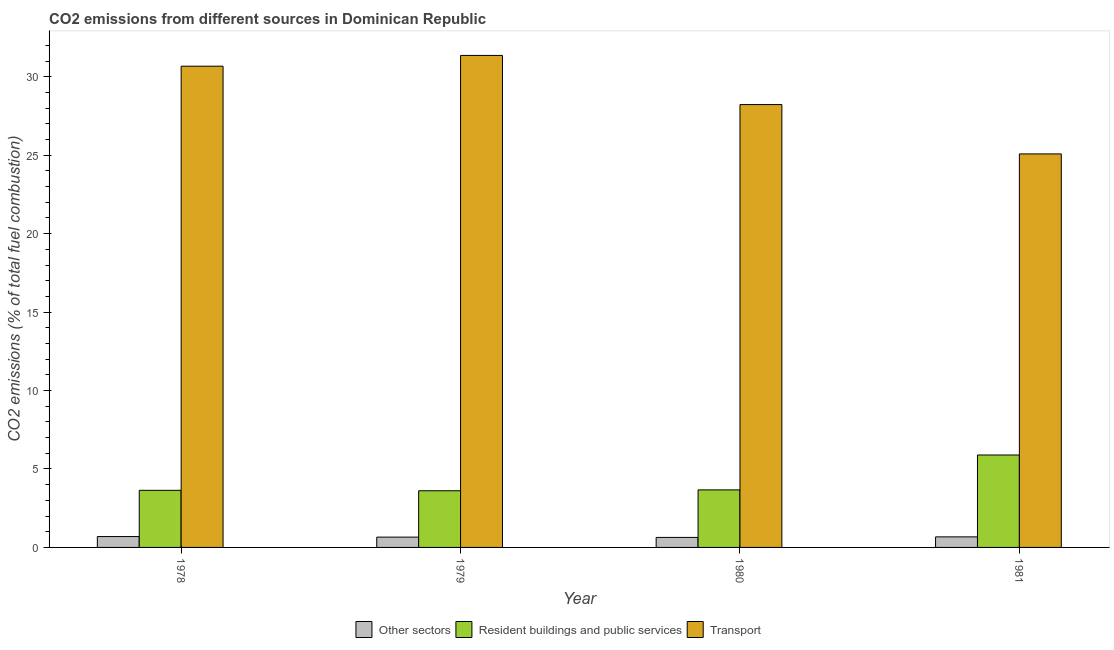How many bars are there on the 3rd tick from the left?
Provide a succinct answer. 3. How many bars are there on the 3rd tick from the right?
Provide a succinct answer. 3. What is the label of the 1st group of bars from the left?
Ensure brevity in your answer.  1978. In how many cases, is the number of bars for a given year not equal to the number of legend labels?
Offer a very short reply. 0. What is the percentage of co2 emissions from other sectors in 1978?
Give a very brief answer. 0.69. Across all years, what is the maximum percentage of co2 emissions from other sectors?
Ensure brevity in your answer.  0.69. Across all years, what is the minimum percentage of co2 emissions from transport?
Offer a terse response. 25.08. In which year was the percentage of co2 emissions from resident buildings and public services minimum?
Offer a terse response. 1979. What is the total percentage of co2 emissions from other sectors in the graph?
Provide a short and direct response. 2.66. What is the difference between the percentage of co2 emissions from resident buildings and public services in 1978 and that in 1979?
Offer a terse response. 0.03. What is the difference between the percentage of co2 emissions from transport in 1978 and the percentage of co2 emissions from other sectors in 1979?
Keep it short and to the point. -0.69. What is the average percentage of co2 emissions from other sectors per year?
Your response must be concise. 0.67. What is the ratio of the percentage of co2 emissions from resident buildings and public services in 1979 to that in 1980?
Keep it short and to the point. 0.98. Is the percentage of co2 emissions from transport in 1979 less than that in 1980?
Provide a succinct answer. No. What is the difference between the highest and the second highest percentage of co2 emissions from transport?
Provide a short and direct response. 0.69. What is the difference between the highest and the lowest percentage of co2 emissions from transport?
Offer a terse response. 6.28. In how many years, is the percentage of co2 emissions from other sectors greater than the average percentage of co2 emissions from other sectors taken over all years?
Provide a short and direct response. 2. Is the sum of the percentage of co2 emissions from transport in 1979 and 1980 greater than the maximum percentage of co2 emissions from resident buildings and public services across all years?
Keep it short and to the point. Yes. What does the 2nd bar from the left in 1980 represents?
Ensure brevity in your answer.  Resident buildings and public services. What does the 3rd bar from the right in 1979 represents?
Keep it short and to the point. Other sectors. What is the title of the graph?
Ensure brevity in your answer.  CO2 emissions from different sources in Dominican Republic. Does "Renewable sources" appear as one of the legend labels in the graph?
Provide a short and direct response. No. What is the label or title of the Y-axis?
Make the answer very short. CO2 emissions (% of total fuel combustion). What is the CO2 emissions (% of total fuel combustion) of Other sectors in 1978?
Your response must be concise. 0.69. What is the CO2 emissions (% of total fuel combustion) of Resident buildings and public services in 1978?
Provide a succinct answer. 3.64. What is the CO2 emissions (% of total fuel combustion) of Transport in 1978?
Make the answer very short. 30.68. What is the CO2 emissions (% of total fuel combustion) in Other sectors in 1979?
Make the answer very short. 0.66. What is the CO2 emissions (% of total fuel combustion) of Resident buildings and public services in 1979?
Provide a short and direct response. 3.61. What is the CO2 emissions (% of total fuel combustion) of Transport in 1979?
Provide a short and direct response. 31.36. What is the CO2 emissions (% of total fuel combustion) of Other sectors in 1980?
Make the answer very short. 0.64. What is the CO2 emissions (% of total fuel combustion) of Resident buildings and public services in 1980?
Your answer should be very brief. 3.67. What is the CO2 emissions (% of total fuel combustion) of Transport in 1980?
Provide a succinct answer. 28.23. What is the CO2 emissions (% of total fuel combustion) in Other sectors in 1981?
Give a very brief answer. 0.67. What is the CO2 emissions (% of total fuel combustion) of Resident buildings and public services in 1981?
Make the answer very short. 5.89. What is the CO2 emissions (% of total fuel combustion) of Transport in 1981?
Keep it short and to the point. 25.08. Across all years, what is the maximum CO2 emissions (% of total fuel combustion) in Other sectors?
Your answer should be compact. 0.69. Across all years, what is the maximum CO2 emissions (% of total fuel combustion) in Resident buildings and public services?
Provide a short and direct response. 5.89. Across all years, what is the maximum CO2 emissions (% of total fuel combustion) in Transport?
Give a very brief answer. 31.36. Across all years, what is the minimum CO2 emissions (% of total fuel combustion) of Other sectors?
Your answer should be compact. 0.64. Across all years, what is the minimum CO2 emissions (% of total fuel combustion) in Resident buildings and public services?
Provide a succinct answer. 3.61. Across all years, what is the minimum CO2 emissions (% of total fuel combustion) in Transport?
Your answer should be compact. 25.08. What is the total CO2 emissions (% of total fuel combustion) in Other sectors in the graph?
Give a very brief answer. 2.66. What is the total CO2 emissions (% of total fuel combustion) in Resident buildings and public services in the graph?
Offer a terse response. 16.81. What is the total CO2 emissions (% of total fuel combustion) of Transport in the graph?
Offer a terse response. 115.35. What is the difference between the CO2 emissions (% of total fuel combustion) in Other sectors in 1978 and that in 1979?
Your answer should be very brief. 0.04. What is the difference between the CO2 emissions (% of total fuel combustion) in Resident buildings and public services in 1978 and that in 1979?
Provide a succinct answer. 0.03. What is the difference between the CO2 emissions (% of total fuel combustion) in Transport in 1978 and that in 1979?
Make the answer very short. -0.69. What is the difference between the CO2 emissions (% of total fuel combustion) of Other sectors in 1978 and that in 1980?
Offer a terse response. 0.06. What is the difference between the CO2 emissions (% of total fuel combustion) of Resident buildings and public services in 1978 and that in 1980?
Provide a succinct answer. -0.03. What is the difference between the CO2 emissions (% of total fuel combustion) of Transport in 1978 and that in 1980?
Make the answer very short. 2.45. What is the difference between the CO2 emissions (% of total fuel combustion) of Other sectors in 1978 and that in 1981?
Offer a very short reply. 0.02. What is the difference between the CO2 emissions (% of total fuel combustion) in Resident buildings and public services in 1978 and that in 1981?
Provide a short and direct response. -2.25. What is the difference between the CO2 emissions (% of total fuel combustion) of Transport in 1978 and that in 1981?
Keep it short and to the point. 5.59. What is the difference between the CO2 emissions (% of total fuel combustion) of Other sectors in 1979 and that in 1980?
Offer a very short reply. 0.02. What is the difference between the CO2 emissions (% of total fuel combustion) in Resident buildings and public services in 1979 and that in 1980?
Offer a terse response. -0.06. What is the difference between the CO2 emissions (% of total fuel combustion) of Transport in 1979 and that in 1980?
Ensure brevity in your answer.  3.13. What is the difference between the CO2 emissions (% of total fuel combustion) in Other sectors in 1979 and that in 1981?
Offer a terse response. -0.02. What is the difference between the CO2 emissions (% of total fuel combustion) in Resident buildings and public services in 1979 and that in 1981?
Offer a very short reply. -2.28. What is the difference between the CO2 emissions (% of total fuel combustion) in Transport in 1979 and that in 1981?
Ensure brevity in your answer.  6.28. What is the difference between the CO2 emissions (% of total fuel combustion) in Other sectors in 1980 and that in 1981?
Your response must be concise. -0.04. What is the difference between the CO2 emissions (% of total fuel combustion) in Resident buildings and public services in 1980 and that in 1981?
Your answer should be compact. -2.22. What is the difference between the CO2 emissions (% of total fuel combustion) in Transport in 1980 and that in 1981?
Offer a terse response. 3.15. What is the difference between the CO2 emissions (% of total fuel combustion) in Other sectors in 1978 and the CO2 emissions (% of total fuel combustion) in Resident buildings and public services in 1979?
Your answer should be very brief. -2.92. What is the difference between the CO2 emissions (% of total fuel combustion) in Other sectors in 1978 and the CO2 emissions (% of total fuel combustion) in Transport in 1979?
Your answer should be very brief. -30.67. What is the difference between the CO2 emissions (% of total fuel combustion) of Resident buildings and public services in 1978 and the CO2 emissions (% of total fuel combustion) of Transport in 1979?
Make the answer very short. -27.72. What is the difference between the CO2 emissions (% of total fuel combustion) in Other sectors in 1978 and the CO2 emissions (% of total fuel combustion) in Resident buildings and public services in 1980?
Your response must be concise. -2.98. What is the difference between the CO2 emissions (% of total fuel combustion) in Other sectors in 1978 and the CO2 emissions (% of total fuel combustion) in Transport in 1980?
Your response must be concise. -27.54. What is the difference between the CO2 emissions (% of total fuel combustion) of Resident buildings and public services in 1978 and the CO2 emissions (% of total fuel combustion) of Transport in 1980?
Provide a succinct answer. -24.59. What is the difference between the CO2 emissions (% of total fuel combustion) in Other sectors in 1978 and the CO2 emissions (% of total fuel combustion) in Resident buildings and public services in 1981?
Ensure brevity in your answer.  -5.2. What is the difference between the CO2 emissions (% of total fuel combustion) of Other sectors in 1978 and the CO2 emissions (% of total fuel combustion) of Transport in 1981?
Your response must be concise. -24.39. What is the difference between the CO2 emissions (% of total fuel combustion) of Resident buildings and public services in 1978 and the CO2 emissions (% of total fuel combustion) of Transport in 1981?
Make the answer very short. -21.44. What is the difference between the CO2 emissions (% of total fuel combustion) in Other sectors in 1979 and the CO2 emissions (% of total fuel combustion) in Resident buildings and public services in 1980?
Provide a short and direct response. -3.01. What is the difference between the CO2 emissions (% of total fuel combustion) of Other sectors in 1979 and the CO2 emissions (% of total fuel combustion) of Transport in 1980?
Your answer should be very brief. -27.57. What is the difference between the CO2 emissions (% of total fuel combustion) of Resident buildings and public services in 1979 and the CO2 emissions (% of total fuel combustion) of Transport in 1980?
Your answer should be compact. -24.62. What is the difference between the CO2 emissions (% of total fuel combustion) in Other sectors in 1979 and the CO2 emissions (% of total fuel combustion) in Resident buildings and public services in 1981?
Offer a very short reply. -5.24. What is the difference between the CO2 emissions (% of total fuel combustion) in Other sectors in 1979 and the CO2 emissions (% of total fuel combustion) in Transport in 1981?
Offer a very short reply. -24.43. What is the difference between the CO2 emissions (% of total fuel combustion) in Resident buildings and public services in 1979 and the CO2 emissions (% of total fuel combustion) in Transport in 1981?
Your response must be concise. -21.47. What is the difference between the CO2 emissions (% of total fuel combustion) in Other sectors in 1980 and the CO2 emissions (% of total fuel combustion) in Resident buildings and public services in 1981?
Give a very brief answer. -5.25. What is the difference between the CO2 emissions (% of total fuel combustion) in Other sectors in 1980 and the CO2 emissions (% of total fuel combustion) in Transport in 1981?
Your answer should be very brief. -24.45. What is the difference between the CO2 emissions (% of total fuel combustion) of Resident buildings and public services in 1980 and the CO2 emissions (% of total fuel combustion) of Transport in 1981?
Give a very brief answer. -21.42. What is the average CO2 emissions (% of total fuel combustion) in Other sectors per year?
Your answer should be compact. 0.67. What is the average CO2 emissions (% of total fuel combustion) of Resident buildings and public services per year?
Offer a terse response. 4.2. What is the average CO2 emissions (% of total fuel combustion) of Transport per year?
Your answer should be compact. 28.84. In the year 1978, what is the difference between the CO2 emissions (% of total fuel combustion) of Other sectors and CO2 emissions (% of total fuel combustion) of Resident buildings and public services?
Ensure brevity in your answer.  -2.95. In the year 1978, what is the difference between the CO2 emissions (% of total fuel combustion) in Other sectors and CO2 emissions (% of total fuel combustion) in Transport?
Keep it short and to the point. -29.98. In the year 1978, what is the difference between the CO2 emissions (% of total fuel combustion) of Resident buildings and public services and CO2 emissions (% of total fuel combustion) of Transport?
Ensure brevity in your answer.  -27.04. In the year 1979, what is the difference between the CO2 emissions (% of total fuel combustion) in Other sectors and CO2 emissions (% of total fuel combustion) in Resident buildings and public services?
Give a very brief answer. -2.96. In the year 1979, what is the difference between the CO2 emissions (% of total fuel combustion) in Other sectors and CO2 emissions (% of total fuel combustion) in Transport?
Give a very brief answer. -30.71. In the year 1979, what is the difference between the CO2 emissions (% of total fuel combustion) of Resident buildings and public services and CO2 emissions (% of total fuel combustion) of Transport?
Provide a succinct answer. -27.75. In the year 1980, what is the difference between the CO2 emissions (% of total fuel combustion) of Other sectors and CO2 emissions (% of total fuel combustion) of Resident buildings and public services?
Provide a short and direct response. -3.03. In the year 1980, what is the difference between the CO2 emissions (% of total fuel combustion) of Other sectors and CO2 emissions (% of total fuel combustion) of Transport?
Ensure brevity in your answer.  -27.59. In the year 1980, what is the difference between the CO2 emissions (% of total fuel combustion) of Resident buildings and public services and CO2 emissions (% of total fuel combustion) of Transport?
Your answer should be compact. -24.56. In the year 1981, what is the difference between the CO2 emissions (% of total fuel combustion) of Other sectors and CO2 emissions (% of total fuel combustion) of Resident buildings and public services?
Ensure brevity in your answer.  -5.22. In the year 1981, what is the difference between the CO2 emissions (% of total fuel combustion) of Other sectors and CO2 emissions (% of total fuel combustion) of Transport?
Offer a very short reply. -24.41. In the year 1981, what is the difference between the CO2 emissions (% of total fuel combustion) in Resident buildings and public services and CO2 emissions (% of total fuel combustion) in Transport?
Give a very brief answer. -19.19. What is the ratio of the CO2 emissions (% of total fuel combustion) in Other sectors in 1978 to that in 1979?
Make the answer very short. 1.06. What is the ratio of the CO2 emissions (% of total fuel combustion) of Resident buildings and public services in 1978 to that in 1979?
Your answer should be compact. 1.01. What is the ratio of the CO2 emissions (% of total fuel combustion) in Transport in 1978 to that in 1979?
Make the answer very short. 0.98. What is the ratio of the CO2 emissions (% of total fuel combustion) in Other sectors in 1978 to that in 1980?
Offer a very short reply. 1.09. What is the ratio of the CO2 emissions (% of total fuel combustion) in Resident buildings and public services in 1978 to that in 1980?
Your response must be concise. 0.99. What is the ratio of the CO2 emissions (% of total fuel combustion) of Transport in 1978 to that in 1980?
Offer a terse response. 1.09. What is the ratio of the CO2 emissions (% of total fuel combustion) of Other sectors in 1978 to that in 1981?
Make the answer very short. 1.03. What is the ratio of the CO2 emissions (% of total fuel combustion) in Resident buildings and public services in 1978 to that in 1981?
Offer a terse response. 0.62. What is the ratio of the CO2 emissions (% of total fuel combustion) in Transport in 1978 to that in 1981?
Provide a short and direct response. 1.22. What is the ratio of the CO2 emissions (% of total fuel combustion) in Other sectors in 1979 to that in 1980?
Ensure brevity in your answer.  1.03. What is the ratio of the CO2 emissions (% of total fuel combustion) of Resident buildings and public services in 1979 to that in 1980?
Keep it short and to the point. 0.98. What is the ratio of the CO2 emissions (% of total fuel combustion) in Transport in 1979 to that in 1980?
Your answer should be compact. 1.11. What is the ratio of the CO2 emissions (% of total fuel combustion) in Other sectors in 1979 to that in 1981?
Give a very brief answer. 0.98. What is the ratio of the CO2 emissions (% of total fuel combustion) of Resident buildings and public services in 1979 to that in 1981?
Provide a succinct answer. 0.61. What is the ratio of the CO2 emissions (% of total fuel combustion) of Transport in 1979 to that in 1981?
Provide a succinct answer. 1.25. What is the ratio of the CO2 emissions (% of total fuel combustion) in Other sectors in 1980 to that in 1981?
Your answer should be compact. 0.95. What is the ratio of the CO2 emissions (% of total fuel combustion) in Resident buildings and public services in 1980 to that in 1981?
Give a very brief answer. 0.62. What is the ratio of the CO2 emissions (% of total fuel combustion) of Transport in 1980 to that in 1981?
Your response must be concise. 1.13. What is the difference between the highest and the second highest CO2 emissions (% of total fuel combustion) in Other sectors?
Your answer should be compact. 0.02. What is the difference between the highest and the second highest CO2 emissions (% of total fuel combustion) of Resident buildings and public services?
Keep it short and to the point. 2.22. What is the difference between the highest and the second highest CO2 emissions (% of total fuel combustion) of Transport?
Give a very brief answer. 0.69. What is the difference between the highest and the lowest CO2 emissions (% of total fuel combustion) of Other sectors?
Give a very brief answer. 0.06. What is the difference between the highest and the lowest CO2 emissions (% of total fuel combustion) in Resident buildings and public services?
Provide a succinct answer. 2.28. What is the difference between the highest and the lowest CO2 emissions (% of total fuel combustion) of Transport?
Your answer should be very brief. 6.28. 